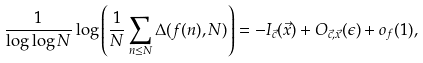Convert formula to latex. <formula><loc_0><loc_0><loc_500><loc_500>\frac { 1 } { \log \log N } \log \left ( \frac { 1 } { N } \sum _ { n \leq N } \Delta ( f ( n ) , N ) \right ) = - I _ { \vec { c } } ( \vec { x } ) + O _ { \vec { c } , \vec { x } } ( \epsilon ) + o _ { f } ( 1 ) ,</formula> 